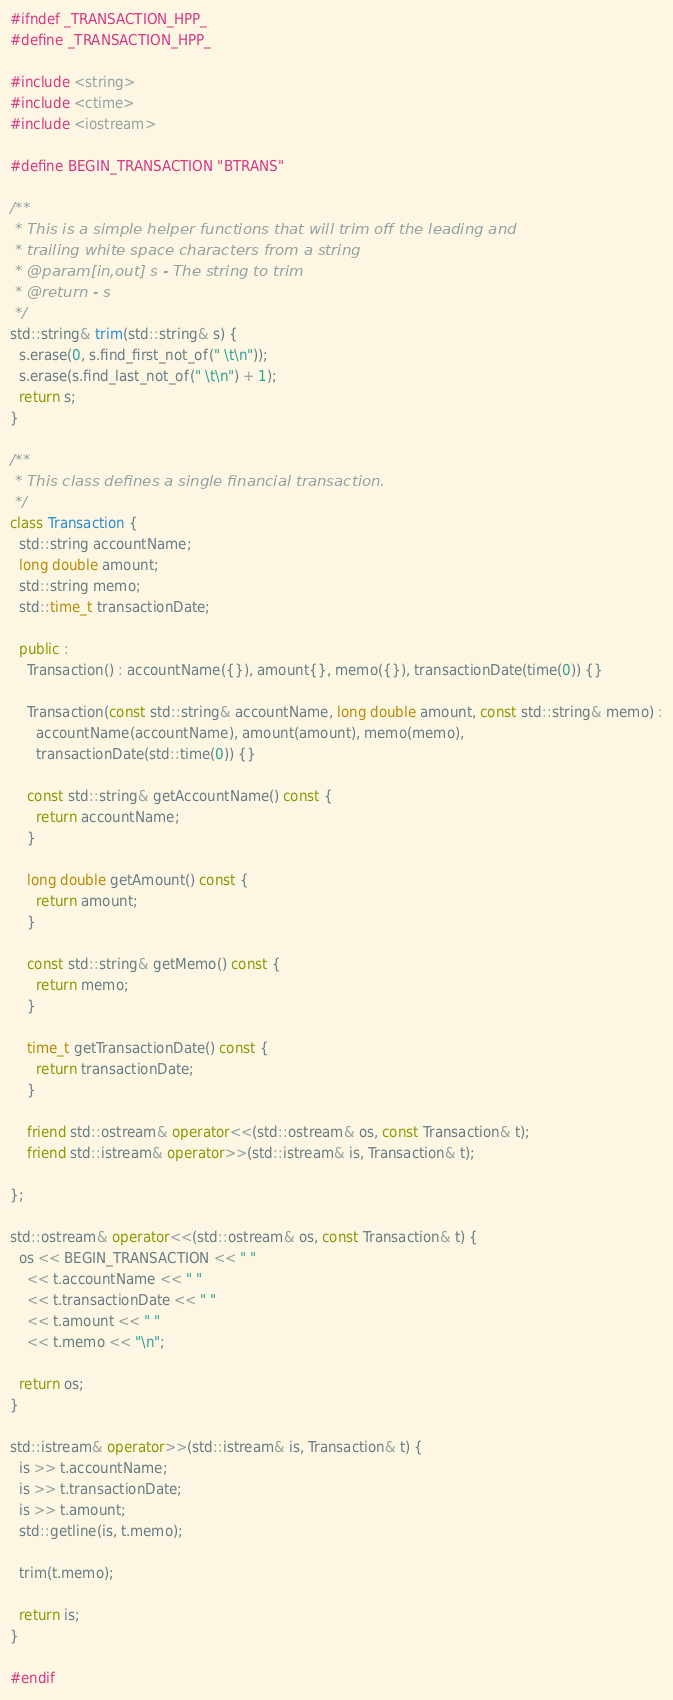Convert code to text. <code><loc_0><loc_0><loc_500><loc_500><_C++_>#ifndef _TRANSACTION_HPP_
#define _TRANSACTION_HPP_

#include <string>
#include <ctime>
#include <iostream>

#define BEGIN_TRANSACTION "BTRANS"

/**
 * This is a simple helper functions that will trim off the leading and 
 * trailing white space characters from a string
 * @param[in,out] s - The string to trim
 * @return - s
 */
std::string& trim(std::string& s) {
  s.erase(0, s.find_first_not_of(" \t\n"));
  s.erase(s.find_last_not_of(" \t\n") + 1);
  return s;
}

/**
 * This class defines a single financial transaction. 
 */
class Transaction {
  std::string accountName;
  long double amount;
  std::string memo;
  std::time_t transactionDate;

  public :
    Transaction() : accountName({}), amount{}, memo({}), transactionDate(time(0)) {}  

    Transaction(const std::string& accountName, long double amount, const std::string& memo) :
      accountName(accountName), amount(amount), memo(memo), 
      transactionDate(std::time(0)) {}

    const std::string& getAccountName() const {
      return accountName;
    }

    long double getAmount() const {
      return amount;
    }

    const std::string& getMemo() const {
      return memo;
    }

    time_t getTransactionDate() const {
      return transactionDate;
    }

    friend std::ostream& operator<<(std::ostream& os, const Transaction& t);
    friend std::istream& operator>>(std::istream& is, Transaction& t);

};

std::ostream& operator<<(std::ostream& os, const Transaction& t) {
  os << BEGIN_TRANSACTION << " " 
    << t.accountName << " "
    << t.transactionDate << " "
    << t.amount << " "
    << t.memo << "\n";

  return os;
}

std::istream& operator>>(std::istream& is, Transaction& t) {
  is >> t.accountName;
  is >> t.transactionDate;
  is >> t.amount;
  std::getline(is, t.memo);

  trim(t.memo);

  return is;
}

#endif 
</code> 